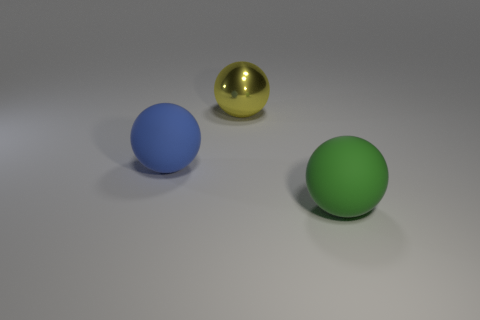How many matte things are tiny gray things or big objects?
Your answer should be compact. 2. Is the number of rubber things that are behind the shiny sphere greater than the number of metal balls that are left of the large green sphere?
Your answer should be compact. No. How many other objects are there of the same size as the green matte ball?
Your response must be concise. 2. What size is the rubber ball behind the large thing that is to the right of the large yellow metallic object?
Ensure brevity in your answer.  Large. How many tiny things are either green matte spheres or blue spheres?
Give a very brief answer. 0. There is a rubber object that is to the left of the big rubber ball on the right side of the matte object that is behind the large green rubber object; what size is it?
Offer a terse response. Large. Is there any other thing that has the same color as the metal sphere?
Provide a short and direct response. No. The large thing that is to the left of the large yellow shiny object that is on the left side of the large rubber object in front of the blue sphere is made of what material?
Ensure brevity in your answer.  Rubber. Is the shape of the large yellow shiny object the same as the blue object?
Give a very brief answer. Yes. Are there any other things that are made of the same material as the large yellow object?
Your response must be concise. No. 